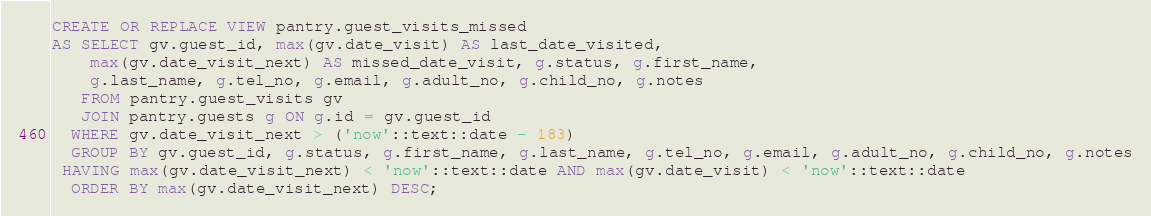Convert code to text. <code><loc_0><loc_0><loc_500><loc_500><_SQL_>CREATE OR REPLACE VIEW pantry.guest_visits_missed
AS SELECT gv.guest_id, max(gv.date_visit) AS last_date_visited, 
    max(gv.date_visit_next) AS missed_date_visit, g.status, g.first_name, 
    g.last_name, g.tel_no, g.email, g.adult_no, g.child_no, g.notes
   FROM pantry.guest_visits gv
   JOIN pantry.guests g ON g.id = gv.guest_id
  WHERE gv.date_visit_next > ('now'::text::date - 183)
  GROUP BY gv.guest_id, g.status, g.first_name, g.last_name, g.tel_no, g.email, g.adult_no, g.child_no, g.notes
 HAVING max(gv.date_visit_next) < 'now'::text::date AND max(gv.date_visit) < 'now'::text::date
  ORDER BY max(gv.date_visit_next) DESC;
</code> 